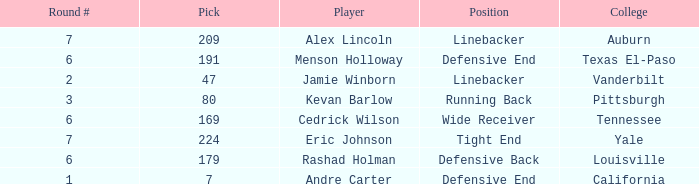Which pick came from Texas El-Paso? 191.0. 